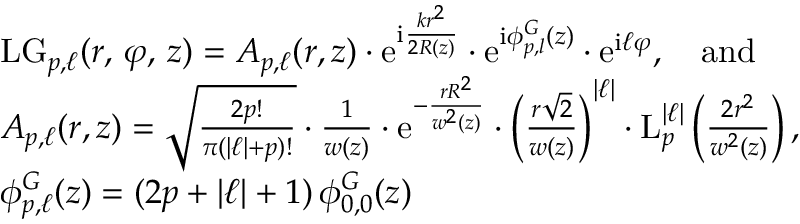<formula> <loc_0><loc_0><loc_500><loc_500>\begin{array} { r l } & { L G _ { p , \ell } ( r , \, \varphi , \, z ) = A _ { p , \ell } ( r , z ) \cdot e ^ { i \frac { k r ^ { 2 } } { 2 R ( z ) } } \cdot e ^ { i \phi _ { p , l } ^ { G } ( z ) } \cdot e ^ { i \ell \varphi } , \quad a n d } \\ & { A _ { p , \ell } ( r , z ) = \sqrt { \frac { 2 p ! } { \pi ( | \ell | + p ) ! } } \cdot \frac { 1 } { w ( z ) } \cdot e ^ { - \frac { r R { ^ { 2 } } } { w ^ { 2 } ( z ) } } \cdot \left ( \frac { r \sqrt { 2 } } { w ( z ) } \right ) ^ { | \ell | } \cdot L _ { p } ^ { | \ell | } \left ( \frac { 2 r ^ { 2 } } { w ^ { 2 } ( z ) } \right ) , } \\ & { \phi _ { p , \ell } ^ { G } ( z ) = ( 2 p + | \ell | + 1 ) \, \phi _ { 0 , 0 } ^ { G } ( z ) } \end{array}</formula> 